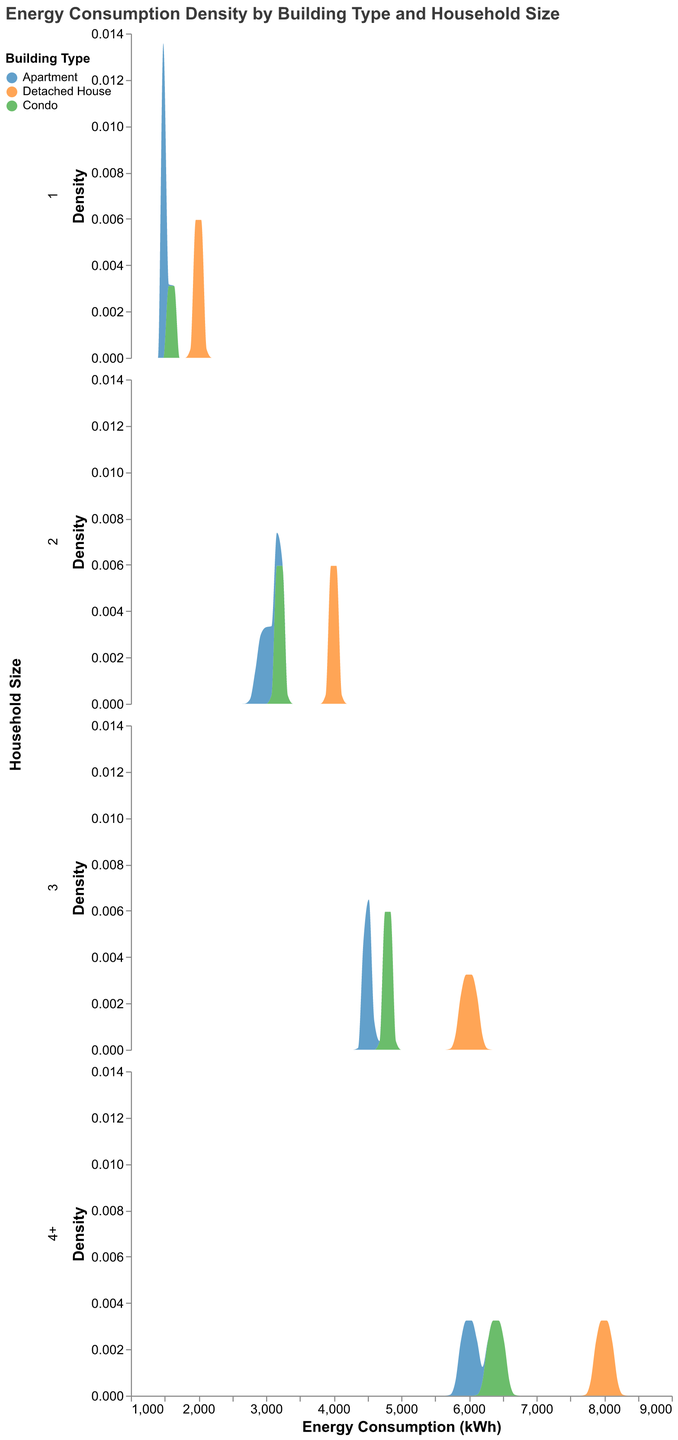What is the title of the figure? The title of the figure can be found at the top of the chart.
Answer: Energy Consumption Density by Building Type and Household Size Which building type has the highest energy consumption density for a household size of 1? To answer this, look at the row corresponding to Household Size 1, and observe the density curves for each building type. The peak of the energy consumption density for Detached House is highest.
Answer: Detached House Comparing households of size 2 and size 3, which building type shows a consistent increase in energy consumption density? Examine the rows corresponding to household sizes 2 and 3. For each building type, observe how the density peaks shift along the x-axis toward higher energy consumption values. All building types show this pattern due to the dataset structure, but Detached House is a clear example of consistent increase.
Answer: Detached House In the plot for household size 4+, which building type has the most spread-out density distribution? To assess the spread, look at the width of each density curve along the x-axis. For household size 4+, the energy consumption density curve for Detached House is the widest.
Answer: Detached House How does the energy consumption density for condos change as household size increases? Observe the density plots for condos across each household size. As the household size increases, the peak energy consumption density shifts to higher values (e.g., from approximately 1600 kWh for size 1 to 6400 kWh for size 4+).
Answer: Peaks shift to higher values What is the energy consumption range covered by the density plots? The x-axis shows the range of energy consumption values. Each row has density plots extending between 1000 kWh and 9000 kWh, consistent across all household sizes.
Answer: 1000 kWh to 9000 kWh For a household size of 2, which building type has the lowest peak in energy consumption density? Look at the density curves in the row for household size 2. Identify the peak values and compare them. The energy consumption density for Apartments has the lowest peak.
Answer: Apartment Do detached houses show more variability in energy consumption compared to apartments for any household size? To determine variability, compare the width and shape of density curves for detached houses and apartments in each row. For all household sizes, detached houses show wider spreads and higher peaks indicating more variability.
Answer: Yes Which household size shows the highest peak in energy consumption density overall, and for which building type does this occur? Compare the peaks across all rows and building types. Household size 4+ shows the highest peak for the Detached House density plot.
Answer: 4+, Detached House 